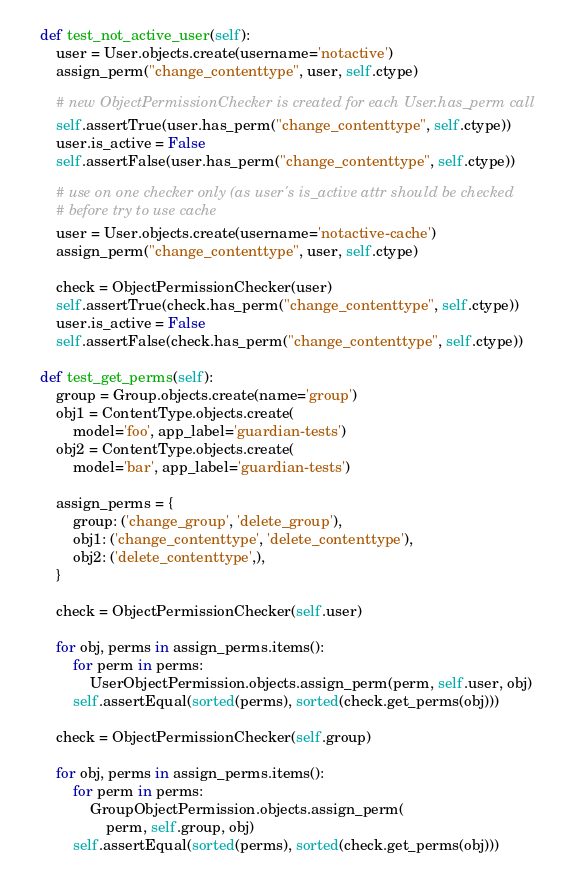Convert code to text. <code><loc_0><loc_0><loc_500><loc_500><_Python_>    def test_not_active_user(self):
        user = User.objects.create(username='notactive')
        assign_perm("change_contenttype", user, self.ctype)

        # new ObjectPermissionChecker is created for each User.has_perm call
        self.assertTrue(user.has_perm("change_contenttype", self.ctype))
        user.is_active = False
        self.assertFalse(user.has_perm("change_contenttype", self.ctype))

        # use on one checker only (as user's is_active attr should be checked
        # before try to use cache
        user = User.objects.create(username='notactive-cache')
        assign_perm("change_contenttype", user, self.ctype)

        check = ObjectPermissionChecker(user)
        self.assertTrue(check.has_perm("change_contenttype", self.ctype))
        user.is_active = False
        self.assertFalse(check.has_perm("change_contenttype", self.ctype))

    def test_get_perms(self):
        group = Group.objects.create(name='group')
        obj1 = ContentType.objects.create(
            model='foo', app_label='guardian-tests')
        obj2 = ContentType.objects.create(
            model='bar', app_label='guardian-tests')

        assign_perms = {
            group: ('change_group', 'delete_group'),
            obj1: ('change_contenttype', 'delete_contenttype'),
            obj2: ('delete_contenttype',),
        }

        check = ObjectPermissionChecker(self.user)

        for obj, perms in assign_perms.items():
            for perm in perms:
                UserObjectPermission.objects.assign_perm(perm, self.user, obj)
            self.assertEqual(sorted(perms), sorted(check.get_perms(obj)))

        check = ObjectPermissionChecker(self.group)

        for obj, perms in assign_perms.items():
            for perm in perms:
                GroupObjectPermission.objects.assign_perm(
                    perm, self.group, obj)
            self.assertEqual(sorted(perms), sorted(check.get_perms(obj)))
</code> 